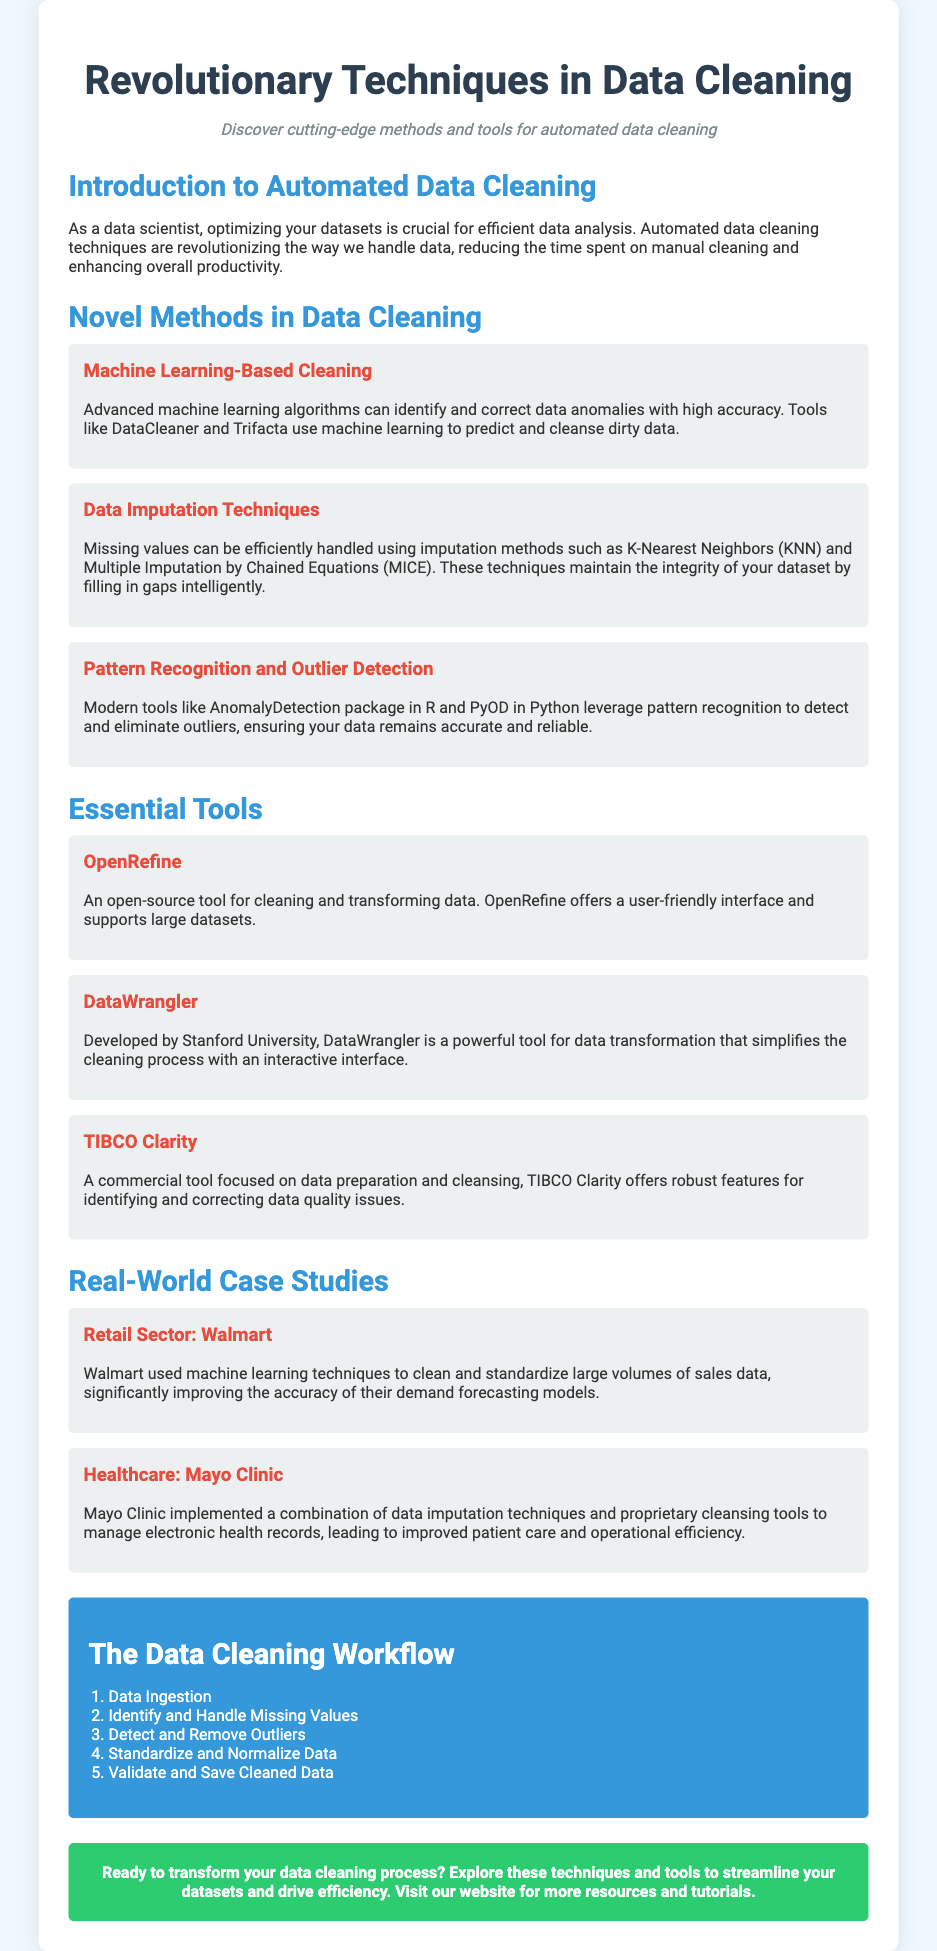What is the title of the flyer? The title of the flyer is prominently displayed at the top of the document, which is "Revolutionary Techniques in Data Cleaning."
Answer: Revolutionary Techniques in Data Cleaning Who is the subheading directed to? The subheading addresses the audience who are interested in the content, specifically data scientists.
Answer: data scientists What is one method used in data cleaning? The document lists multiple methods, and one of them is highlighted with a heading, which is "Machine Learning-Based Cleaning."
Answer: Machine Learning-Based Cleaning What tool is open-source for data cleaning? One of the tools mentioned for data cleaning is specified as open-source, which is "OpenRefine."
Answer: OpenRefine Which retail sector company is mentioned in the case studies? A specific company from the retail sector that implemented data cleaning techniques is mentioned as "Walmart."
Answer: Walmart What is the first step in the data cleaning workflow? The workflow is listed in a specific order, with the first step being "Data Ingestion."
Answer: Data Ingestion What color is used for the infographic section? The infographic section is designed with a specific background color for emphasis, which is "blue."
Answer: blue How many case studies are presented in the flyer? The flyer presents details about two distinct case studies in the healthcare and retail sectors.
Answer: two 